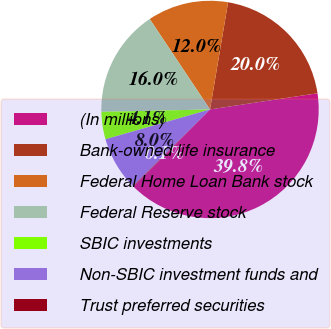Convert chart to OTSL. <chart><loc_0><loc_0><loc_500><loc_500><pie_chart><fcel>(In millions)<fcel>Bank-owned life insurance<fcel>Federal Home Loan Bank stock<fcel>Federal Reserve stock<fcel>SBIC investments<fcel>Non-SBIC investment funds and<fcel>Trust preferred securities<nl><fcel>39.82%<fcel>19.96%<fcel>12.02%<fcel>15.99%<fcel>4.07%<fcel>8.04%<fcel>0.1%<nl></chart> 